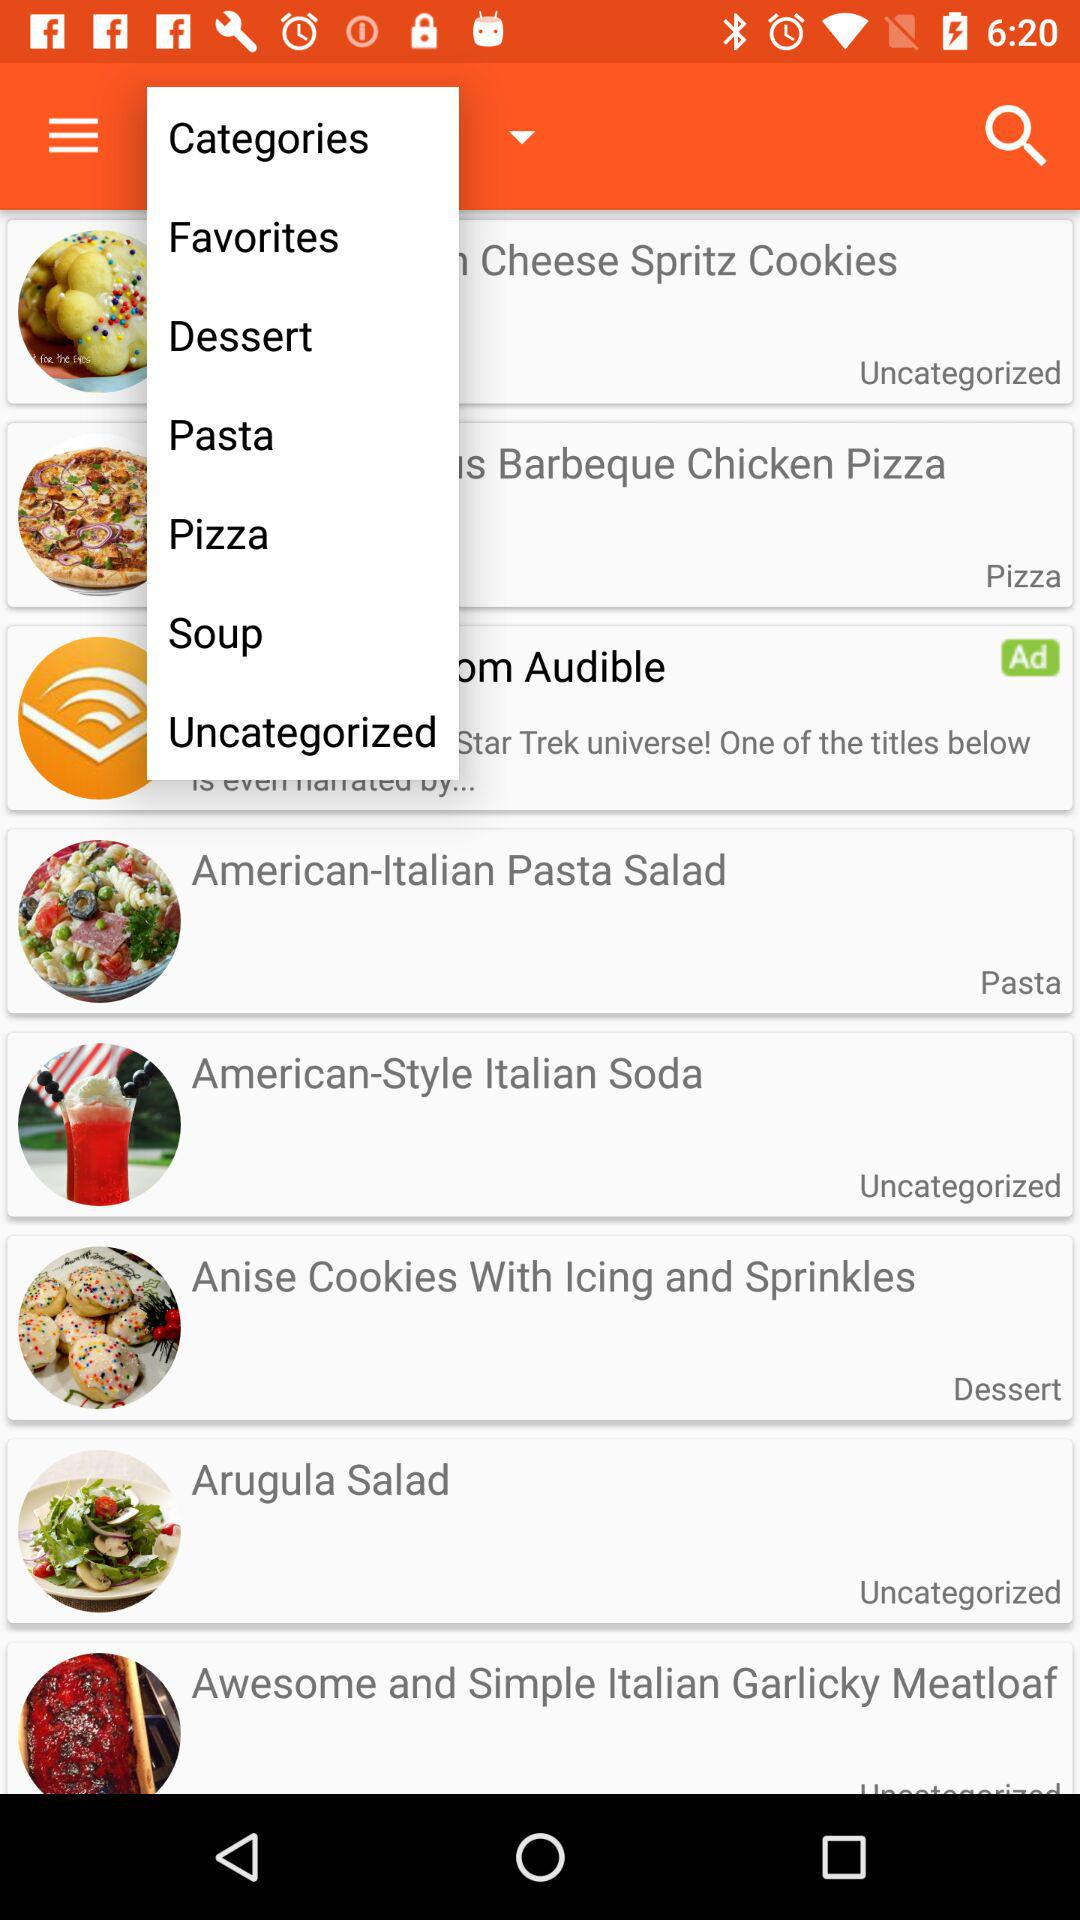What is the category of Arugula Salad? The "Arugula Salad" is Uncategorized. 